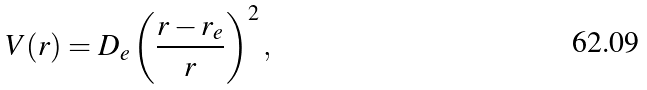<formula> <loc_0><loc_0><loc_500><loc_500>V ( r ) = D _ { e } \left ( \frac { r - r _ { e } } { r } \right ) ^ { 2 } ,</formula> 